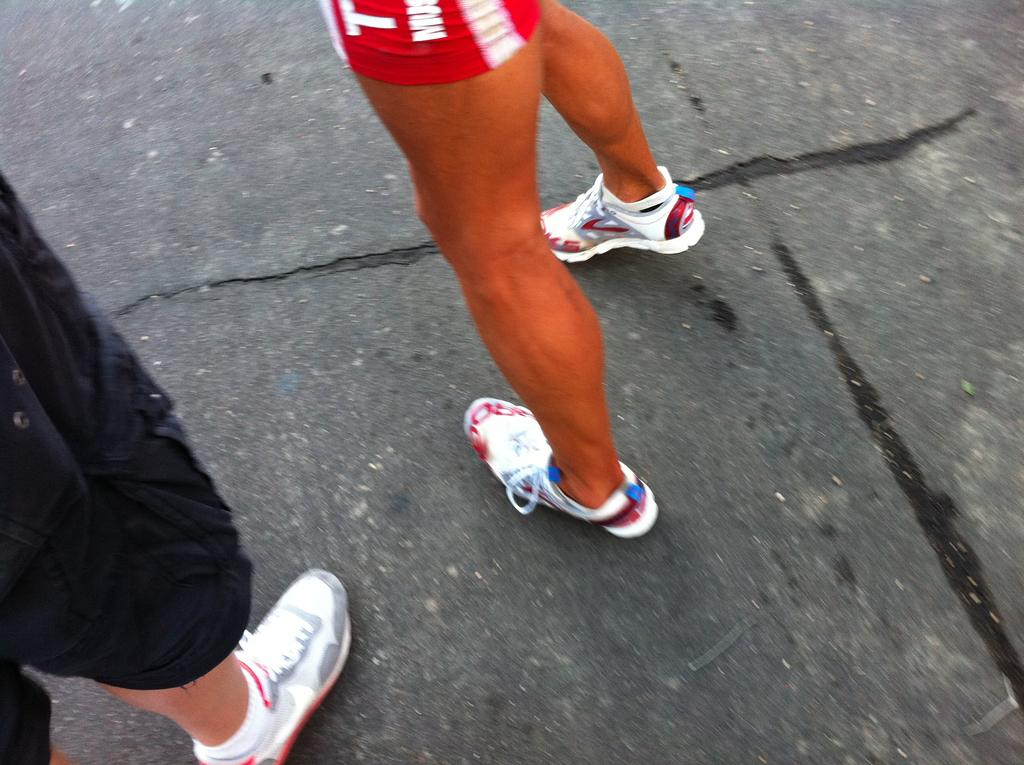How many people are in the image? There are two persons in the image. What are the two persons doing in the image? The two persons are standing on the road. What color is the blood on the frog in the image? There is no frog or blood present in the image; it only features two persons standing on the road. 